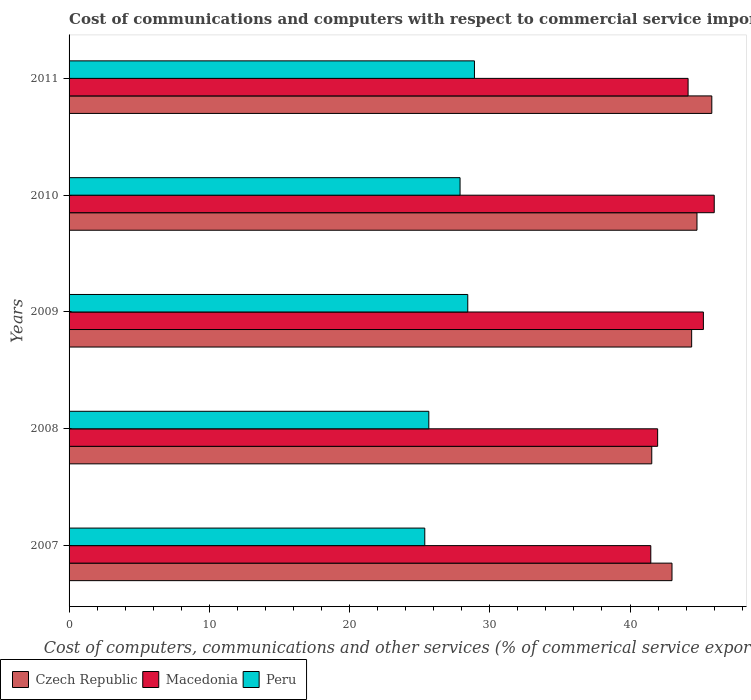How many groups of bars are there?
Your answer should be very brief. 5. Are the number of bars on each tick of the Y-axis equal?
Your answer should be very brief. Yes. How many bars are there on the 5th tick from the top?
Ensure brevity in your answer.  3. What is the label of the 3rd group of bars from the top?
Ensure brevity in your answer.  2009. What is the cost of communications and computers in Czech Republic in 2008?
Offer a very short reply. 41.55. Across all years, what is the maximum cost of communications and computers in Czech Republic?
Keep it short and to the point. 45.83. Across all years, what is the minimum cost of communications and computers in Macedonia?
Offer a terse response. 41.48. In which year was the cost of communications and computers in Czech Republic maximum?
Your answer should be very brief. 2011. In which year was the cost of communications and computers in Macedonia minimum?
Ensure brevity in your answer.  2007. What is the total cost of communications and computers in Macedonia in the graph?
Provide a short and direct response. 218.82. What is the difference between the cost of communications and computers in Macedonia in 2007 and that in 2011?
Keep it short and to the point. -2.66. What is the difference between the cost of communications and computers in Czech Republic in 2010 and the cost of communications and computers in Peru in 2008?
Ensure brevity in your answer.  19.12. What is the average cost of communications and computers in Macedonia per year?
Ensure brevity in your answer.  43.76. In the year 2008, what is the difference between the cost of communications and computers in Macedonia and cost of communications and computers in Peru?
Provide a succinct answer. 16.32. What is the ratio of the cost of communications and computers in Macedonia in 2007 to that in 2009?
Your answer should be very brief. 0.92. Is the cost of communications and computers in Macedonia in 2009 less than that in 2011?
Offer a very short reply. No. Is the difference between the cost of communications and computers in Macedonia in 2009 and 2011 greater than the difference between the cost of communications and computers in Peru in 2009 and 2011?
Keep it short and to the point. Yes. What is the difference between the highest and the second highest cost of communications and computers in Czech Republic?
Keep it short and to the point. 1.06. What is the difference between the highest and the lowest cost of communications and computers in Macedonia?
Provide a succinct answer. 4.52. Is the sum of the cost of communications and computers in Czech Republic in 2008 and 2009 greater than the maximum cost of communications and computers in Macedonia across all years?
Your answer should be compact. Yes. What does the 2nd bar from the top in 2011 represents?
Your response must be concise. Macedonia. What does the 3rd bar from the bottom in 2007 represents?
Your answer should be very brief. Peru. Are all the bars in the graph horizontal?
Keep it short and to the point. Yes. What is the difference between two consecutive major ticks on the X-axis?
Provide a succinct answer. 10. Does the graph contain any zero values?
Provide a short and direct response. No. How are the legend labels stacked?
Offer a very short reply. Horizontal. What is the title of the graph?
Offer a very short reply. Cost of communications and computers with respect to commercial service imports. What is the label or title of the X-axis?
Offer a very short reply. Cost of computers, communications and other services (% of commerical service exports). What is the Cost of computers, communications and other services (% of commerical service exports) of Czech Republic in 2007?
Offer a terse response. 42.99. What is the Cost of computers, communications and other services (% of commerical service exports) in Macedonia in 2007?
Offer a very short reply. 41.48. What is the Cost of computers, communications and other services (% of commerical service exports) of Peru in 2007?
Offer a terse response. 25.36. What is the Cost of computers, communications and other services (% of commerical service exports) in Czech Republic in 2008?
Provide a short and direct response. 41.55. What is the Cost of computers, communications and other services (% of commerical service exports) of Macedonia in 2008?
Your answer should be very brief. 41.97. What is the Cost of computers, communications and other services (% of commerical service exports) of Peru in 2008?
Offer a very short reply. 25.65. What is the Cost of computers, communications and other services (% of commerical service exports) in Czech Republic in 2009?
Keep it short and to the point. 44.39. What is the Cost of computers, communications and other services (% of commerical service exports) in Macedonia in 2009?
Your answer should be compact. 45.23. What is the Cost of computers, communications and other services (% of commerical service exports) in Peru in 2009?
Provide a succinct answer. 28.43. What is the Cost of computers, communications and other services (% of commerical service exports) in Czech Republic in 2010?
Provide a succinct answer. 44.77. What is the Cost of computers, communications and other services (% of commerical service exports) in Macedonia in 2010?
Your answer should be very brief. 46. What is the Cost of computers, communications and other services (% of commerical service exports) of Peru in 2010?
Make the answer very short. 27.88. What is the Cost of computers, communications and other services (% of commerical service exports) in Czech Republic in 2011?
Your answer should be very brief. 45.83. What is the Cost of computers, communications and other services (% of commerical service exports) in Macedonia in 2011?
Offer a very short reply. 44.14. What is the Cost of computers, communications and other services (% of commerical service exports) of Peru in 2011?
Make the answer very short. 28.91. Across all years, what is the maximum Cost of computers, communications and other services (% of commerical service exports) of Czech Republic?
Offer a terse response. 45.83. Across all years, what is the maximum Cost of computers, communications and other services (% of commerical service exports) of Macedonia?
Your answer should be compact. 46. Across all years, what is the maximum Cost of computers, communications and other services (% of commerical service exports) in Peru?
Offer a very short reply. 28.91. Across all years, what is the minimum Cost of computers, communications and other services (% of commerical service exports) in Czech Republic?
Your answer should be compact. 41.55. Across all years, what is the minimum Cost of computers, communications and other services (% of commerical service exports) of Macedonia?
Your answer should be compact. 41.48. Across all years, what is the minimum Cost of computers, communications and other services (% of commerical service exports) in Peru?
Ensure brevity in your answer.  25.36. What is the total Cost of computers, communications and other services (% of commerical service exports) of Czech Republic in the graph?
Offer a very short reply. 219.54. What is the total Cost of computers, communications and other services (% of commerical service exports) in Macedonia in the graph?
Your answer should be very brief. 218.82. What is the total Cost of computers, communications and other services (% of commerical service exports) of Peru in the graph?
Ensure brevity in your answer.  136.23. What is the difference between the Cost of computers, communications and other services (% of commerical service exports) in Czech Republic in 2007 and that in 2008?
Provide a short and direct response. 1.44. What is the difference between the Cost of computers, communications and other services (% of commerical service exports) in Macedonia in 2007 and that in 2008?
Provide a short and direct response. -0.49. What is the difference between the Cost of computers, communications and other services (% of commerical service exports) of Peru in 2007 and that in 2008?
Offer a terse response. -0.29. What is the difference between the Cost of computers, communications and other services (% of commerical service exports) of Czech Republic in 2007 and that in 2009?
Offer a terse response. -1.4. What is the difference between the Cost of computers, communications and other services (% of commerical service exports) of Macedonia in 2007 and that in 2009?
Offer a terse response. -3.75. What is the difference between the Cost of computers, communications and other services (% of commerical service exports) in Peru in 2007 and that in 2009?
Your answer should be compact. -3.07. What is the difference between the Cost of computers, communications and other services (% of commerical service exports) of Czech Republic in 2007 and that in 2010?
Provide a succinct answer. -1.78. What is the difference between the Cost of computers, communications and other services (% of commerical service exports) in Macedonia in 2007 and that in 2010?
Your answer should be compact. -4.52. What is the difference between the Cost of computers, communications and other services (% of commerical service exports) in Peru in 2007 and that in 2010?
Give a very brief answer. -2.52. What is the difference between the Cost of computers, communications and other services (% of commerical service exports) of Czech Republic in 2007 and that in 2011?
Make the answer very short. -2.84. What is the difference between the Cost of computers, communications and other services (% of commerical service exports) of Macedonia in 2007 and that in 2011?
Offer a terse response. -2.66. What is the difference between the Cost of computers, communications and other services (% of commerical service exports) in Peru in 2007 and that in 2011?
Make the answer very short. -3.54. What is the difference between the Cost of computers, communications and other services (% of commerical service exports) of Czech Republic in 2008 and that in 2009?
Offer a terse response. -2.84. What is the difference between the Cost of computers, communications and other services (% of commerical service exports) of Macedonia in 2008 and that in 2009?
Your response must be concise. -3.26. What is the difference between the Cost of computers, communications and other services (% of commerical service exports) in Peru in 2008 and that in 2009?
Give a very brief answer. -2.78. What is the difference between the Cost of computers, communications and other services (% of commerical service exports) in Czech Republic in 2008 and that in 2010?
Your answer should be compact. -3.23. What is the difference between the Cost of computers, communications and other services (% of commerical service exports) in Macedonia in 2008 and that in 2010?
Provide a succinct answer. -4.03. What is the difference between the Cost of computers, communications and other services (% of commerical service exports) in Peru in 2008 and that in 2010?
Your answer should be compact. -2.23. What is the difference between the Cost of computers, communications and other services (% of commerical service exports) of Czech Republic in 2008 and that in 2011?
Your answer should be very brief. -4.28. What is the difference between the Cost of computers, communications and other services (% of commerical service exports) in Macedonia in 2008 and that in 2011?
Provide a succinct answer. -2.17. What is the difference between the Cost of computers, communications and other services (% of commerical service exports) of Peru in 2008 and that in 2011?
Offer a very short reply. -3.25. What is the difference between the Cost of computers, communications and other services (% of commerical service exports) of Czech Republic in 2009 and that in 2010?
Your response must be concise. -0.38. What is the difference between the Cost of computers, communications and other services (% of commerical service exports) in Macedonia in 2009 and that in 2010?
Offer a terse response. -0.77. What is the difference between the Cost of computers, communications and other services (% of commerical service exports) in Peru in 2009 and that in 2010?
Your answer should be compact. 0.55. What is the difference between the Cost of computers, communications and other services (% of commerical service exports) of Czech Republic in 2009 and that in 2011?
Ensure brevity in your answer.  -1.44. What is the difference between the Cost of computers, communications and other services (% of commerical service exports) of Macedonia in 2009 and that in 2011?
Offer a terse response. 1.09. What is the difference between the Cost of computers, communications and other services (% of commerical service exports) in Peru in 2009 and that in 2011?
Your response must be concise. -0.48. What is the difference between the Cost of computers, communications and other services (% of commerical service exports) in Czech Republic in 2010 and that in 2011?
Provide a succinct answer. -1.06. What is the difference between the Cost of computers, communications and other services (% of commerical service exports) in Macedonia in 2010 and that in 2011?
Ensure brevity in your answer.  1.86. What is the difference between the Cost of computers, communications and other services (% of commerical service exports) in Peru in 2010 and that in 2011?
Your answer should be very brief. -1.03. What is the difference between the Cost of computers, communications and other services (% of commerical service exports) in Czech Republic in 2007 and the Cost of computers, communications and other services (% of commerical service exports) in Macedonia in 2008?
Make the answer very short. 1.02. What is the difference between the Cost of computers, communications and other services (% of commerical service exports) in Czech Republic in 2007 and the Cost of computers, communications and other services (% of commerical service exports) in Peru in 2008?
Provide a succinct answer. 17.34. What is the difference between the Cost of computers, communications and other services (% of commerical service exports) of Macedonia in 2007 and the Cost of computers, communications and other services (% of commerical service exports) of Peru in 2008?
Offer a very short reply. 15.83. What is the difference between the Cost of computers, communications and other services (% of commerical service exports) in Czech Republic in 2007 and the Cost of computers, communications and other services (% of commerical service exports) in Macedonia in 2009?
Your response must be concise. -2.24. What is the difference between the Cost of computers, communications and other services (% of commerical service exports) in Czech Republic in 2007 and the Cost of computers, communications and other services (% of commerical service exports) in Peru in 2009?
Offer a terse response. 14.56. What is the difference between the Cost of computers, communications and other services (% of commerical service exports) in Macedonia in 2007 and the Cost of computers, communications and other services (% of commerical service exports) in Peru in 2009?
Offer a terse response. 13.05. What is the difference between the Cost of computers, communications and other services (% of commerical service exports) of Czech Republic in 2007 and the Cost of computers, communications and other services (% of commerical service exports) of Macedonia in 2010?
Your response must be concise. -3.01. What is the difference between the Cost of computers, communications and other services (% of commerical service exports) in Czech Republic in 2007 and the Cost of computers, communications and other services (% of commerical service exports) in Peru in 2010?
Keep it short and to the point. 15.11. What is the difference between the Cost of computers, communications and other services (% of commerical service exports) in Macedonia in 2007 and the Cost of computers, communications and other services (% of commerical service exports) in Peru in 2010?
Give a very brief answer. 13.6. What is the difference between the Cost of computers, communications and other services (% of commerical service exports) of Czech Republic in 2007 and the Cost of computers, communications and other services (% of commerical service exports) of Macedonia in 2011?
Your response must be concise. -1.15. What is the difference between the Cost of computers, communications and other services (% of commerical service exports) of Czech Republic in 2007 and the Cost of computers, communications and other services (% of commerical service exports) of Peru in 2011?
Ensure brevity in your answer.  14.09. What is the difference between the Cost of computers, communications and other services (% of commerical service exports) of Macedonia in 2007 and the Cost of computers, communications and other services (% of commerical service exports) of Peru in 2011?
Provide a short and direct response. 12.57. What is the difference between the Cost of computers, communications and other services (% of commerical service exports) in Czech Republic in 2008 and the Cost of computers, communications and other services (% of commerical service exports) in Macedonia in 2009?
Provide a succinct answer. -3.68. What is the difference between the Cost of computers, communications and other services (% of commerical service exports) in Czech Republic in 2008 and the Cost of computers, communications and other services (% of commerical service exports) in Peru in 2009?
Offer a terse response. 13.12. What is the difference between the Cost of computers, communications and other services (% of commerical service exports) of Macedonia in 2008 and the Cost of computers, communications and other services (% of commerical service exports) of Peru in 2009?
Make the answer very short. 13.54. What is the difference between the Cost of computers, communications and other services (% of commerical service exports) in Czech Republic in 2008 and the Cost of computers, communications and other services (% of commerical service exports) in Macedonia in 2010?
Provide a short and direct response. -4.45. What is the difference between the Cost of computers, communications and other services (% of commerical service exports) of Czech Republic in 2008 and the Cost of computers, communications and other services (% of commerical service exports) of Peru in 2010?
Your response must be concise. 13.67. What is the difference between the Cost of computers, communications and other services (% of commerical service exports) of Macedonia in 2008 and the Cost of computers, communications and other services (% of commerical service exports) of Peru in 2010?
Give a very brief answer. 14.09. What is the difference between the Cost of computers, communications and other services (% of commerical service exports) of Czech Republic in 2008 and the Cost of computers, communications and other services (% of commerical service exports) of Macedonia in 2011?
Provide a succinct answer. -2.59. What is the difference between the Cost of computers, communications and other services (% of commerical service exports) in Czech Republic in 2008 and the Cost of computers, communications and other services (% of commerical service exports) in Peru in 2011?
Your answer should be very brief. 12.64. What is the difference between the Cost of computers, communications and other services (% of commerical service exports) in Macedonia in 2008 and the Cost of computers, communications and other services (% of commerical service exports) in Peru in 2011?
Provide a short and direct response. 13.06. What is the difference between the Cost of computers, communications and other services (% of commerical service exports) in Czech Republic in 2009 and the Cost of computers, communications and other services (% of commerical service exports) in Macedonia in 2010?
Your response must be concise. -1.61. What is the difference between the Cost of computers, communications and other services (% of commerical service exports) of Czech Republic in 2009 and the Cost of computers, communications and other services (% of commerical service exports) of Peru in 2010?
Offer a very short reply. 16.51. What is the difference between the Cost of computers, communications and other services (% of commerical service exports) of Macedonia in 2009 and the Cost of computers, communications and other services (% of commerical service exports) of Peru in 2010?
Keep it short and to the point. 17.35. What is the difference between the Cost of computers, communications and other services (% of commerical service exports) in Czech Republic in 2009 and the Cost of computers, communications and other services (% of commerical service exports) in Macedonia in 2011?
Provide a short and direct response. 0.25. What is the difference between the Cost of computers, communications and other services (% of commerical service exports) in Czech Republic in 2009 and the Cost of computers, communications and other services (% of commerical service exports) in Peru in 2011?
Keep it short and to the point. 15.49. What is the difference between the Cost of computers, communications and other services (% of commerical service exports) in Macedonia in 2009 and the Cost of computers, communications and other services (% of commerical service exports) in Peru in 2011?
Make the answer very short. 16.32. What is the difference between the Cost of computers, communications and other services (% of commerical service exports) of Czech Republic in 2010 and the Cost of computers, communications and other services (% of commerical service exports) of Macedonia in 2011?
Keep it short and to the point. 0.63. What is the difference between the Cost of computers, communications and other services (% of commerical service exports) in Czech Republic in 2010 and the Cost of computers, communications and other services (% of commerical service exports) in Peru in 2011?
Ensure brevity in your answer.  15.87. What is the difference between the Cost of computers, communications and other services (% of commerical service exports) of Macedonia in 2010 and the Cost of computers, communications and other services (% of commerical service exports) of Peru in 2011?
Keep it short and to the point. 17.1. What is the average Cost of computers, communications and other services (% of commerical service exports) in Czech Republic per year?
Your response must be concise. 43.91. What is the average Cost of computers, communications and other services (% of commerical service exports) of Macedonia per year?
Offer a terse response. 43.76. What is the average Cost of computers, communications and other services (% of commerical service exports) in Peru per year?
Your answer should be very brief. 27.25. In the year 2007, what is the difference between the Cost of computers, communications and other services (% of commerical service exports) in Czech Republic and Cost of computers, communications and other services (% of commerical service exports) in Macedonia?
Ensure brevity in your answer.  1.51. In the year 2007, what is the difference between the Cost of computers, communications and other services (% of commerical service exports) in Czech Republic and Cost of computers, communications and other services (% of commerical service exports) in Peru?
Make the answer very short. 17.63. In the year 2007, what is the difference between the Cost of computers, communications and other services (% of commerical service exports) of Macedonia and Cost of computers, communications and other services (% of commerical service exports) of Peru?
Offer a very short reply. 16.12. In the year 2008, what is the difference between the Cost of computers, communications and other services (% of commerical service exports) in Czech Republic and Cost of computers, communications and other services (% of commerical service exports) in Macedonia?
Ensure brevity in your answer.  -0.42. In the year 2008, what is the difference between the Cost of computers, communications and other services (% of commerical service exports) of Czech Republic and Cost of computers, communications and other services (% of commerical service exports) of Peru?
Make the answer very short. 15.9. In the year 2008, what is the difference between the Cost of computers, communications and other services (% of commerical service exports) of Macedonia and Cost of computers, communications and other services (% of commerical service exports) of Peru?
Make the answer very short. 16.32. In the year 2009, what is the difference between the Cost of computers, communications and other services (% of commerical service exports) of Czech Republic and Cost of computers, communications and other services (% of commerical service exports) of Macedonia?
Provide a short and direct response. -0.84. In the year 2009, what is the difference between the Cost of computers, communications and other services (% of commerical service exports) in Czech Republic and Cost of computers, communications and other services (% of commerical service exports) in Peru?
Give a very brief answer. 15.96. In the year 2009, what is the difference between the Cost of computers, communications and other services (% of commerical service exports) of Macedonia and Cost of computers, communications and other services (% of commerical service exports) of Peru?
Your answer should be very brief. 16.8. In the year 2010, what is the difference between the Cost of computers, communications and other services (% of commerical service exports) of Czech Republic and Cost of computers, communications and other services (% of commerical service exports) of Macedonia?
Offer a terse response. -1.23. In the year 2010, what is the difference between the Cost of computers, communications and other services (% of commerical service exports) in Czech Republic and Cost of computers, communications and other services (% of commerical service exports) in Peru?
Give a very brief answer. 16.89. In the year 2010, what is the difference between the Cost of computers, communications and other services (% of commerical service exports) in Macedonia and Cost of computers, communications and other services (% of commerical service exports) in Peru?
Provide a short and direct response. 18.12. In the year 2011, what is the difference between the Cost of computers, communications and other services (% of commerical service exports) in Czech Republic and Cost of computers, communications and other services (% of commerical service exports) in Macedonia?
Make the answer very short. 1.69. In the year 2011, what is the difference between the Cost of computers, communications and other services (% of commerical service exports) of Czech Republic and Cost of computers, communications and other services (% of commerical service exports) of Peru?
Make the answer very short. 16.92. In the year 2011, what is the difference between the Cost of computers, communications and other services (% of commerical service exports) in Macedonia and Cost of computers, communications and other services (% of commerical service exports) in Peru?
Ensure brevity in your answer.  15.23. What is the ratio of the Cost of computers, communications and other services (% of commerical service exports) of Czech Republic in 2007 to that in 2008?
Provide a succinct answer. 1.03. What is the ratio of the Cost of computers, communications and other services (% of commerical service exports) of Macedonia in 2007 to that in 2008?
Offer a very short reply. 0.99. What is the ratio of the Cost of computers, communications and other services (% of commerical service exports) in Peru in 2007 to that in 2008?
Offer a terse response. 0.99. What is the ratio of the Cost of computers, communications and other services (% of commerical service exports) in Czech Republic in 2007 to that in 2009?
Provide a short and direct response. 0.97. What is the ratio of the Cost of computers, communications and other services (% of commerical service exports) of Macedonia in 2007 to that in 2009?
Your answer should be compact. 0.92. What is the ratio of the Cost of computers, communications and other services (% of commerical service exports) of Peru in 2007 to that in 2009?
Provide a short and direct response. 0.89. What is the ratio of the Cost of computers, communications and other services (% of commerical service exports) in Czech Republic in 2007 to that in 2010?
Keep it short and to the point. 0.96. What is the ratio of the Cost of computers, communications and other services (% of commerical service exports) of Macedonia in 2007 to that in 2010?
Your answer should be very brief. 0.9. What is the ratio of the Cost of computers, communications and other services (% of commerical service exports) of Peru in 2007 to that in 2010?
Ensure brevity in your answer.  0.91. What is the ratio of the Cost of computers, communications and other services (% of commerical service exports) in Czech Republic in 2007 to that in 2011?
Keep it short and to the point. 0.94. What is the ratio of the Cost of computers, communications and other services (% of commerical service exports) of Macedonia in 2007 to that in 2011?
Give a very brief answer. 0.94. What is the ratio of the Cost of computers, communications and other services (% of commerical service exports) in Peru in 2007 to that in 2011?
Your response must be concise. 0.88. What is the ratio of the Cost of computers, communications and other services (% of commerical service exports) in Czech Republic in 2008 to that in 2009?
Offer a very short reply. 0.94. What is the ratio of the Cost of computers, communications and other services (% of commerical service exports) in Macedonia in 2008 to that in 2009?
Your answer should be compact. 0.93. What is the ratio of the Cost of computers, communications and other services (% of commerical service exports) of Peru in 2008 to that in 2009?
Offer a very short reply. 0.9. What is the ratio of the Cost of computers, communications and other services (% of commerical service exports) of Czech Republic in 2008 to that in 2010?
Provide a short and direct response. 0.93. What is the ratio of the Cost of computers, communications and other services (% of commerical service exports) of Macedonia in 2008 to that in 2010?
Give a very brief answer. 0.91. What is the ratio of the Cost of computers, communications and other services (% of commerical service exports) in Peru in 2008 to that in 2010?
Make the answer very short. 0.92. What is the ratio of the Cost of computers, communications and other services (% of commerical service exports) in Czech Republic in 2008 to that in 2011?
Your answer should be compact. 0.91. What is the ratio of the Cost of computers, communications and other services (% of commerical service exports) of Macedonia in 2008 to that in 2011?
Your answer should be very brief. 0.95. What is the ratio of the Cost of computers, communications and other services (% of commerical service exports) of Peru in 2008 to that in 2011?
Your response must be concise. 0.89. What is the ratio of the Cost of computers, communications and other services (% of commerical service exports) in Macedonia in 2009 to that in 2010?
Ensure brevity in your answer.  0.98. What is the ratio of the Cost of computers, communications and other services (% of commerical service exports) of Peru in 2009 to that in 2010?
Make the answer very short. 1.02. What is the ratio of the Cost of computers, communications and other services (% of commerical service exports) in Czech Republic in 2009 to that in 2011?
Give a very brief answer. 0.97. What is the ratio of the Cost of computers, communications and other services (% of commerical service exports) of Macedonia in 2009 to that in 2011?
Keep it short and to the point. 1.02. What is the ratio of the Cost of computers, communications and other services (% of commerical service exports) of Peru in 2009 to that in 2011?
Your response must be concise. 0.98. What is the ratio of the Cost of computers, communications and other services (% of commerical service exports) in Czech Republic in 2010 to that in 2011?
Make the answer very short. 0.98. What is the ratio of the Cost of computers, communications and other services (% of commerical service exports) of Macedonia in 2010 to that in 2011?
Your answer should be compact. 1.04. What is the ratio of the Cost of computers, communications and other services (% of commerical service exports) of Peru in 2010 to that in 2011?
Give a very brief answer. 0.96. What is the difference between the highest and the second highest Cost of computers, communications and other services (% of commerical service exports) in Czech Republic?
Offer a terse response. 1.06. What is the difference between the highest and the second highest Cost of computers, communications and other services (% of commerical service exports) in Macedonia?
Keep it short and to the point. 0.77. What is the difference between the highest and the second highest Cost of computers, communications and other services (% of commerical service exports) of Peru?
Provide a short and direct response. 0.48. What is the difference between the highest and the lowest Cost of computers, communications and other services (% of commerical service exports) of Czech Republic?
Offer a terse response. 4.28. What is the difference between the highest and the lowest Cost of computers, communications and other services (% of commerical service exports) of Macedonia?
Give a very brief answer. 4.52. What is the difference between the highest and the lowest Cost of computers, communications and other services (% of commerical service exports) of Peru?
Offer a very short reply. 3.54. 